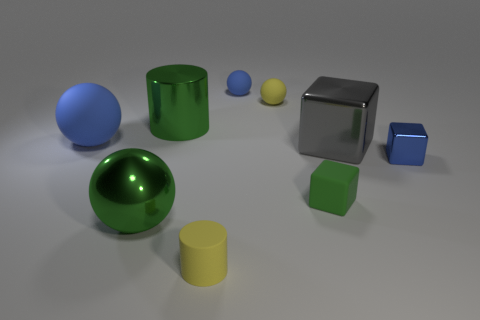Could you explain the lighting setup based on the shadows seen in the image? Certainly. The shadows cast by the objects suggest a single light source positioned above and to the right of the scene. The diffused nature of the shadows indicates that the light source is not overly harsh, which helps in creating a soft and even illumination on the objects. 